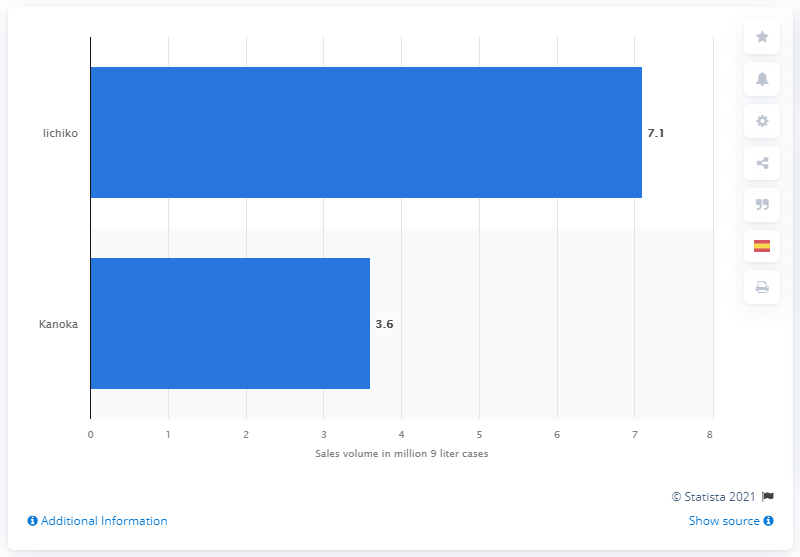Draw attention to some important aspects in this diagram. In 2020, it is reported that Iichiko was the leading global brand of shochu. 